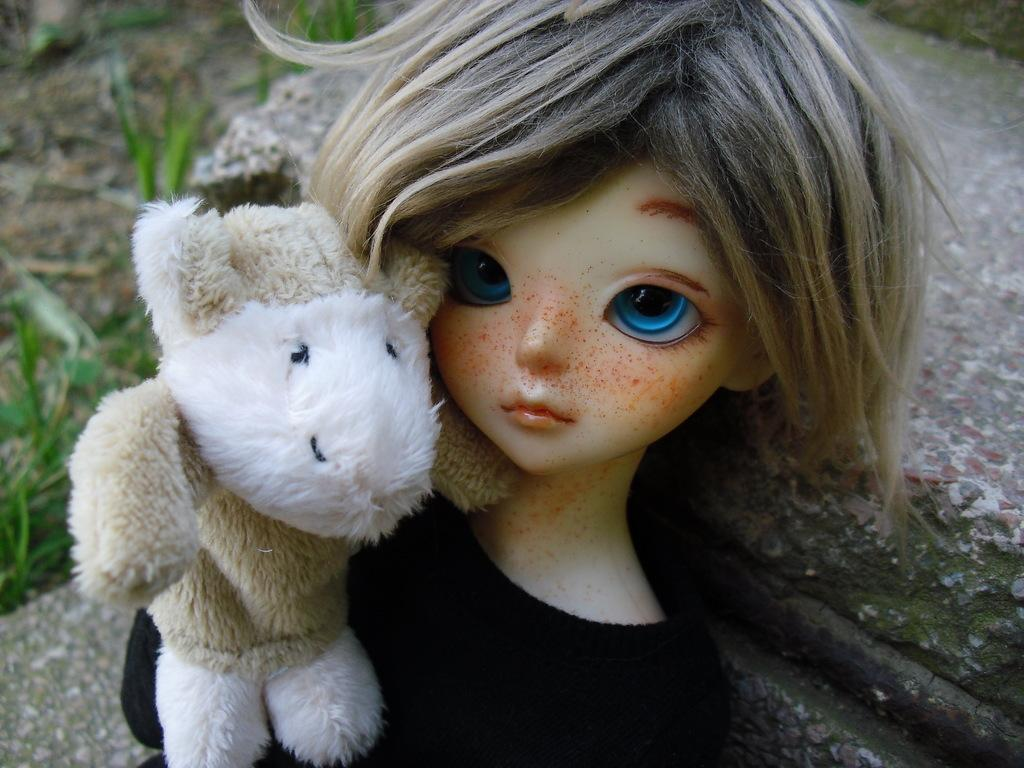What objects can be seen in the image? There are toys in the image. Can you describe the background of the image? The background of the image is blurred. What is the opinion of the soap in the crowd in the image? There is no soap or crowd present in the image; it only features toys and a blurred background. 